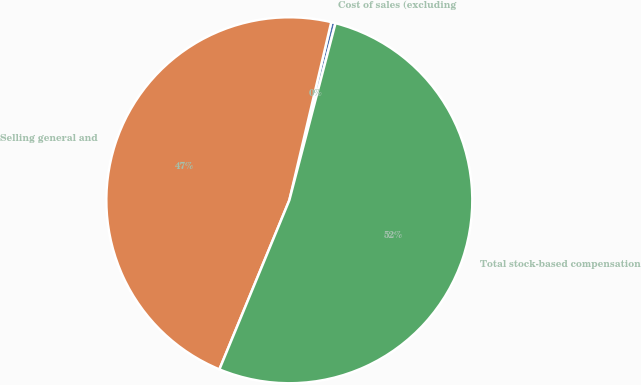Convert chart. <chart><loc_0><loc_0><loc_500><loc_500><pie_chart><fcel>Cost of sales (excluding<fcel>Selling general and<fcel>Total stock-based compensation<nl><fcel>0.38%<fcel>47.44%<fcel>52.18%<nl></chart> 